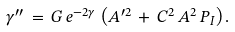<formula> <loc_0><loc_0><loc_500><loc_500>\gamma ^ { \prime \prime } \, = \, G \, e ^ { - 2 \gamma } \, \left ( { A } ^ { \prime 2 } \, + \, C ^ { 2 } \, { A } ^ { 2 } \, P _ { I } \right ) .</formula> 